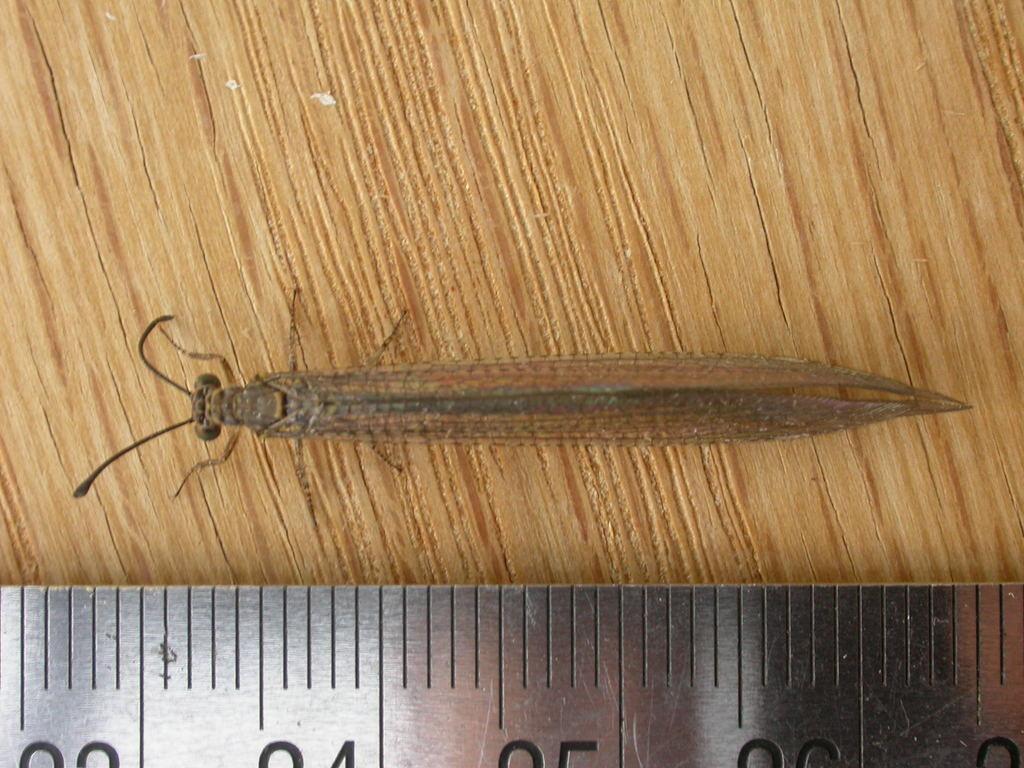How would you summarize this image in a sentence or two? In this image we can see a measuring scale and an insect on a wooden platform. 